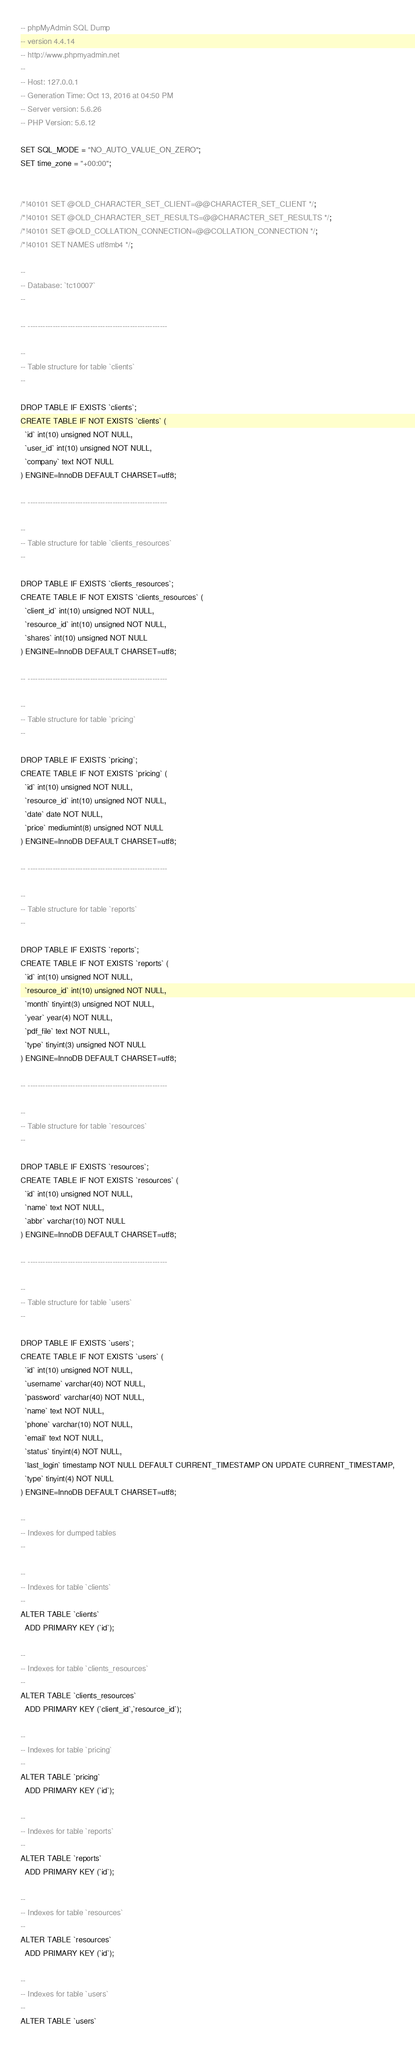<code> <loc_0><loc_0><loc_500><loc_500><_SQL_>-- phpMyAdmin SQL Dump
-- version 4.4.14
-- http://www.phpmyadmin.net
--
-- Host: 127.0.0.1
-- Generation Time: Oct 13, 2016 at 04:50 PM
-- Server version: 5.6.26
-- PHP Version: 5.6.12

SET SQL_MODE = "NO_AUTO_VALUE_ON_ZERO";
SET time_zone = "+00:00";


/*!40101 SET @OLD_CHARACTER_SET_CLIENT=@@CHARACTER_SET_CLIENT */;
/*!40101 SET @OLD_CHARACTER_SET_RESULTS=@@CHARACTER_SET_RESULTS */;
/*!40101 SET @OLD_COLLATION_CONNECTION=@@COLLATION_CONNECTION */;
/*!40101 SET NAMES utf8mb4 */;

--
-- Database: `tc10007`
--

-- --------------------------------------------------------

--
-- Table structure for table `clients`
--

DROP TABLE IF EXISTS `clients`;
CREATE TABLE IF NOT EXISTS `clients` (
  `id` int(10) unsigned NOT NULL,
  `user_id` int(10) unsigned NOT NULL,
  `company` text NOT NULL
) ENGINE=InnoDB DEFAULT CHARSET=utf8;

-- --------------------------------------------------------

--
-- Table structure for table `clients_resources`
--

DROP TABLE IF EXISTS `clients_resources`;
CREATE TABLE IF NOT EXISTS `clients_resources` (
  `client_id` int(10) unsigned NOT NULL,
  `resource_id` int(10) unsigned NOT NULL,
  `shares` int(10) unsigned NOT NULL
) ENGINE=InnoDB DEFAULT CHARSET=utf8;

-- --------------------------------------------------------

--
-- Table structure for table `pricing`
--

DROP TABLE IF EXISTS `pricing`;
CREATE TABLE IF NOT EXISTS `pricing` (
  `id` int(10) unsigned NOT NULL,
  `resource_id` int(10) unsigned NOT NULL,
  `date` date NOT NULL,
  `price` mediumint(8) unsigned NOT NULL
) ENGINE=InnoDB DEFAULT CHARSET=utf8;

-- --------------------------------------------------------

--
-- Table structure for table `reports`
--

DROP TABLE IF EXISTS `reports`;
CREATE TABLE IF NOT EXISTS `reports` (
  `id` int(10) unsigned NOT NULL,
  `resource_id` int(10) unsigned NOT NULL,
  `month` tinyint(3) unsigned NOT NULL,
  `year` year(4) NOT NULL,
  `pdf_file` text NOT NULL,
  `type` tinyint(3) unsigned NOT NULL
) ENGINE=InnoDB DEFAULT CHARSET=utf8;

-- --------------------------------------------------------

--
-- Table structure for table `resources`
--

DROP TABLE IF EXISTS `resources`;
CREATE TABLE IF NOT EXISTS `resources` (
  `id` int(10) unsigned NOT NULL,
  `name` text NOT NULL,
  `abbr` varchar(10) NOT NULL
) ENGINE=InnoDB DEFAULT CHARSET=utf8;

-- --------------------------------------------------------

--
-- Table structure for table `users`
--

DROP TABLE IF EXISTS `users`;
CREATE TABLE IF NOT EXISTS `users` (
  `id` int(10) unsigned NOT NULL,
  `username` varchar(40) NOT NULL,
  `password` varchar(40) NOT NULL,
  `name` text NOT NULL,
  `phone` varchar(10) NOT NULL,
  `email` text NOT NULL,
  `status` tinyint(4) NOT NULL,
  `last_login` timestamp NOT NULL DEFAULT CURRENT_TIMESTAMP ON UPDATE CURRENT_TIMESTAMP,
  `type` tinyint(4) NOT NULL
) ENGINE=InnoDB DEFAULT CHARSET=utf8;

--
-- Indexes for dumped tables
--

--
-- Indexes for table `clients`
--
ALTER TABLE `clients`
  ADD PRIMARY KEY (`id`);

--
-- Indexes for table `clients_resources`
--
ALTER TABLE `clients_resources`
  ADD PRIMARY KEY (`client_id`,`resource_id`);

--
-- Indexes for table `pricing`
--
ALTER TABLE `pricing`
  ADD PRIMARY KEY (`id`);

--
-- Indexes for table `reports`
--
ALTER TABLE `reports`
  ADD PRIMARY KEY (`id`);

--
-- Indexes for table `resources`
--
ALTER TABLE `resources`
  ADD PRIMARY KEY (`id`);

--
-- Indexes for table `users`
--
ALTER TABLE `users`</code> 